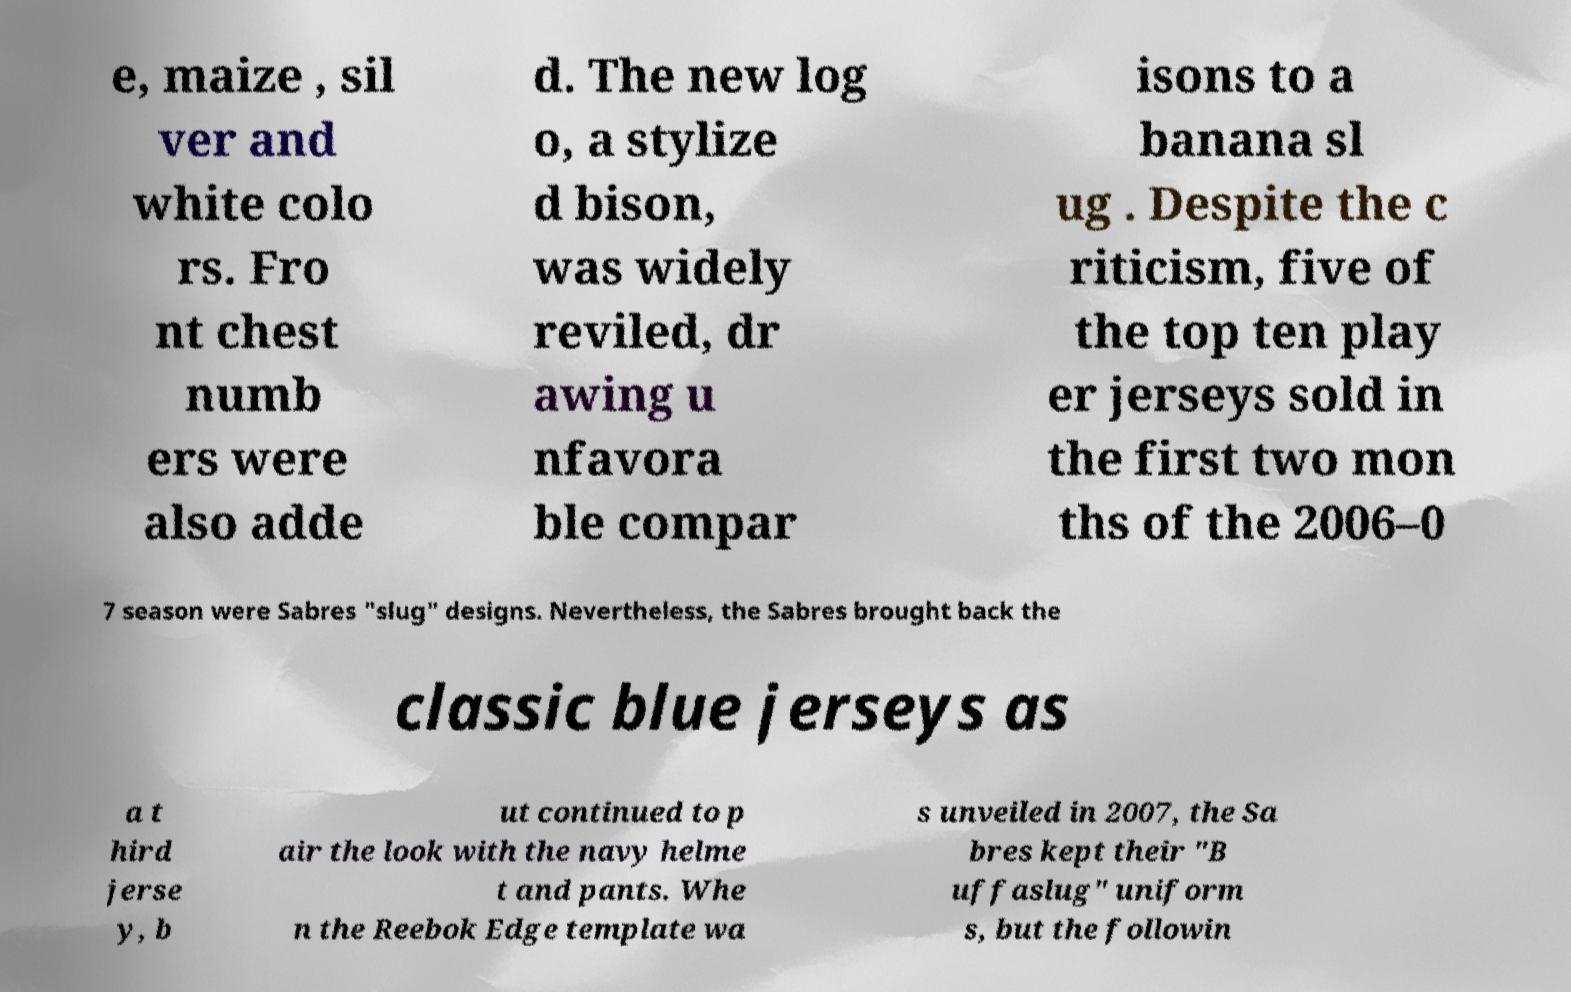Can you read and provide the text displayed in the image?This photo seems to have some interesting text. Can you extract and type it out for me? e, maize , sil ver and white colo rs. Fro nt chest numb ers were also adde d. The new log o, a stylize d bison, was widely reviled, dr awing u nfavora ble compar isons to a banana sl ug . Despite the c riticism, five of the top ten play er jerseys sold in the first two mon ths of the 2006–0 7 season were Sabres "slug" designs. Nevertheless, the Sabres brought back the classic blue jerseys as a t hird jerse y, b ut continued to p air the look with the navy helme t and pants. Whe n the Reebok Edge template wa s unveiled in 2007, the Sa bres kept their "B uffaslug" uniform s, but the followin 